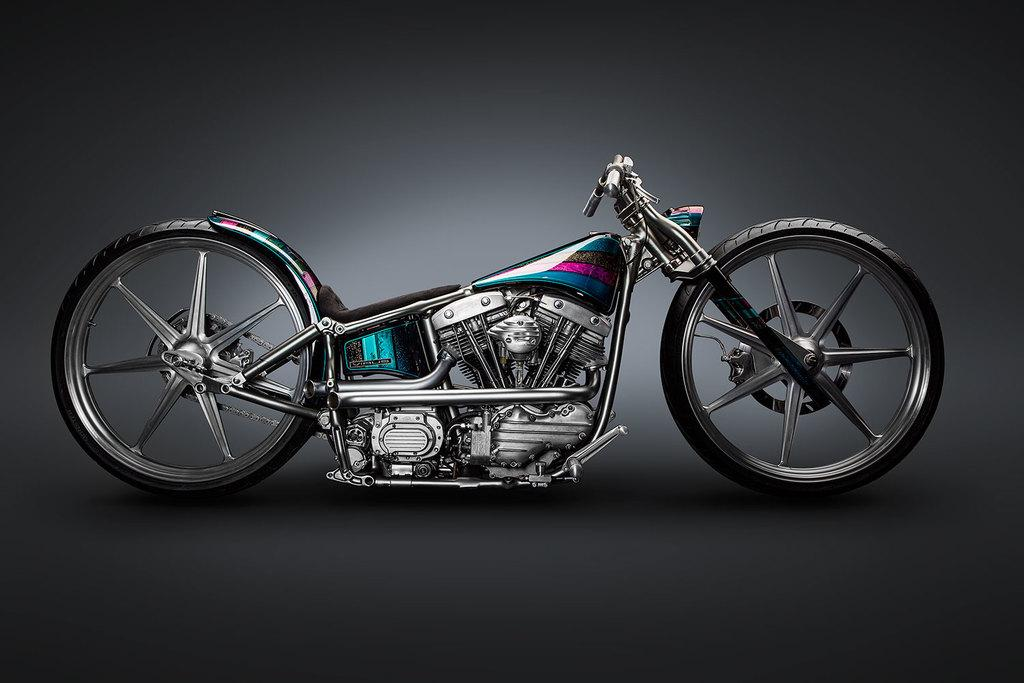What is the main subject of the image? The main subject of the image is a bike. Can you describe the background of the image? The background of the image is grey. How does the bike get a new haircut in the image? The bike does not get a haircut in the image, as it is an inanimate object and cannot have a haircut. 